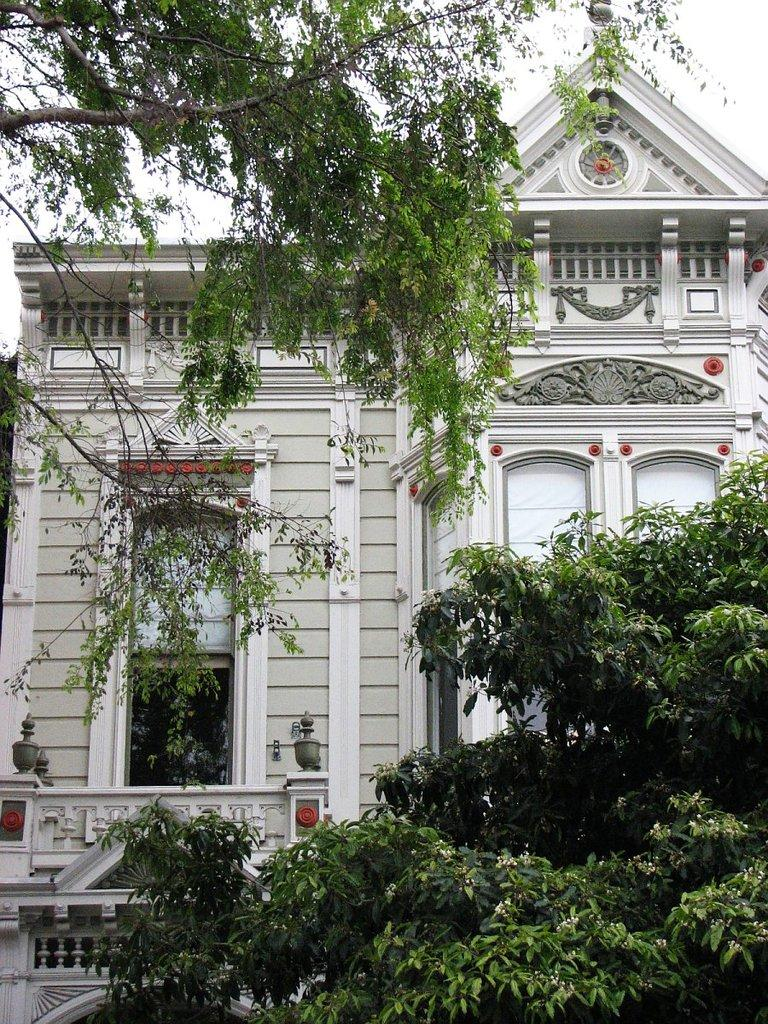What type of vegetation can be seen in the image? There are trees in the image. What type of structure is visible in the image? There is a house with a window in the image. What is visible in the background of the image? The sky is visible in the background of the image. How many books can be seen on the donkey in the image? There are no books or donkeys present in the image. What type of butter is being used to paint the house in the image? There is no butter present in the image, and the house is not being painted. 